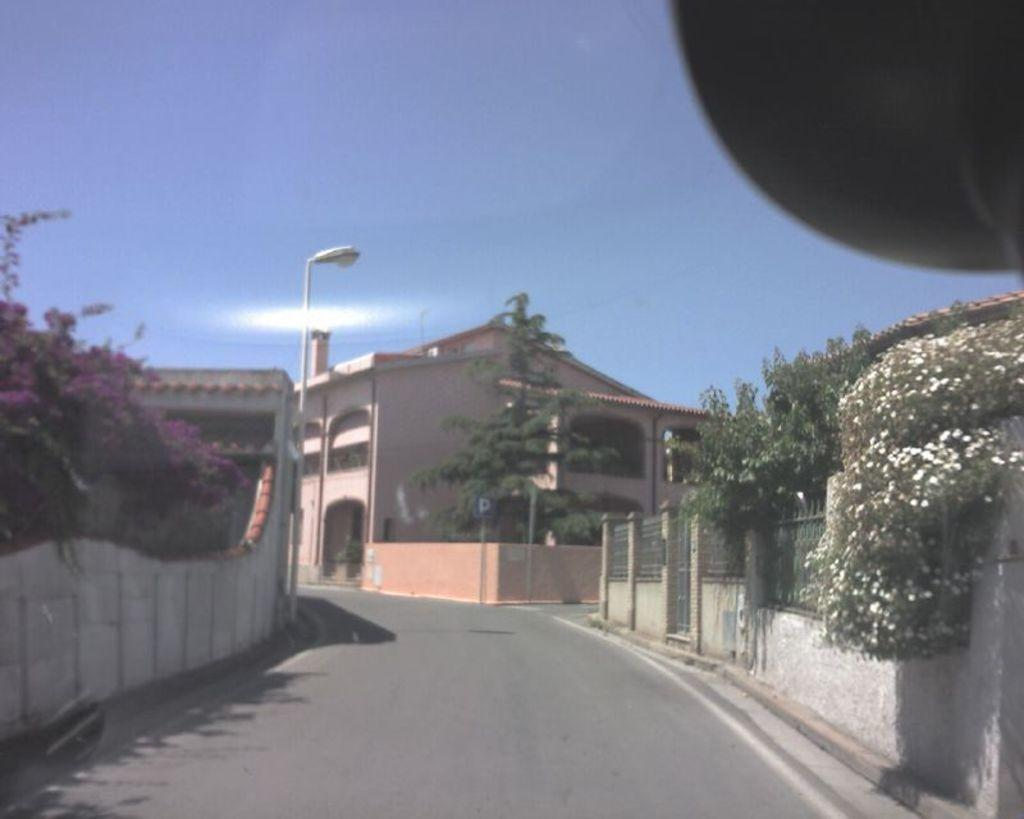What type of structures are present in the image? There are buildings in the image. What other natural elements can be seen in the image? There are trees in the image. What type of lighting is present in the image? There is a pole light in the image. What color is the sky in the image? The sky is blue in the image. Is there steam coming out of the buildings in the image? There is no steam present in the image. Is the ground covered in snow in the image? There is no snow present in the image. 